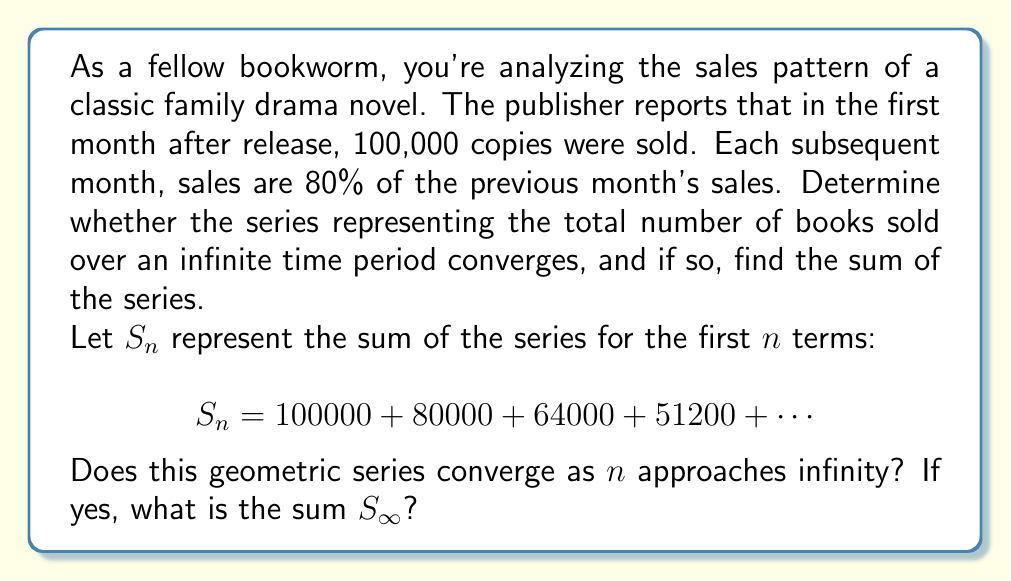Give your solution to this math problem. To determine the convergence and sum of this geometric series, let's follow these steps:

1) Identify the first term and common ratio:
   $a = 100000$ (first term)
   $r = 0.8$ (common ratio, as each term is 80% of the previous)

2) For a geometric series to converge, the absolute value of the common ratio must be less than 1:
   $|r| < 1$
   In this case, $|0.8| < 1$, so the series converges.

3) For a convergent geometric series, the sum to infinity is given by the formula:
   $$S_{\infty} = \frac{a}{1-r}$$
   Where $a$ is the first term and $r$ is the common ratio.

4) Substituting our values:
   $$S_{\infty} = \frac{100000}{1-0.8}$$

5) Simplify:
   $$S_{\infty} = \frac{100000}{0.2} = 500000$$

Therefore, the series converges, and the total number of books sold over an infinite time period would be 500,000.

This result makes sense in the context of book sales. It suggests that while sales decrease each month, the total number of books sold approaches but never exceeds 500,000.
Answer: The geometric series converges. The sum of the series as $n$ approaches infinity is $S_{\infty} = 500000$ books. 